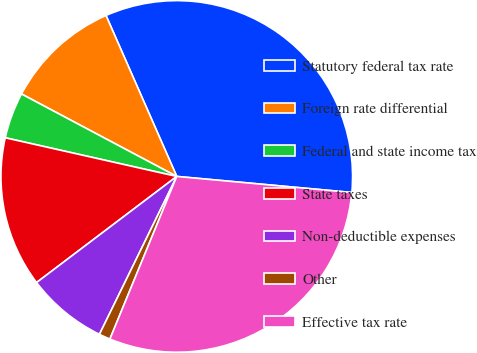Convert chart. <chart><loc_0><loc_0><loc_500><loc_500><pie_chart><fcel>Statutory federal tax rate<fcel>Foreign rate differential<fcel>Federal and state income tax<fcel>State taxes<fcel>Non-deductible expenses<fcel>Other<fcel>Effective tax rate<nl><fcel>33.05%<fcel>10.64%<fcel>4.24%<fcel>13.84%<fcel>7.44%<fcel>1.04%<fcel>29.75%<nl></chart> 